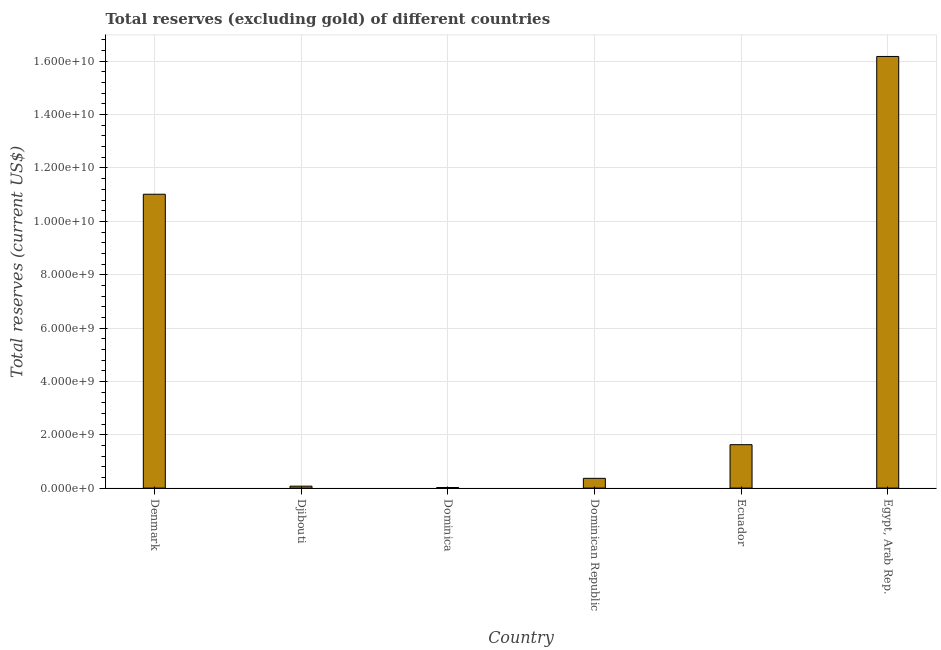What is the title of the graph?
Your answer should be compact. Total reserves (excluding gold) of different countries. What is the label or title of the X-axis?
Keep it short and to the point. Country. What is the label or title of the Y-axis?
Offer a terse response. Total reserves (current US$). What is the total reserves (excluding gold) in Dominica?
Your answer should be very brief. 2.21e+07. Across all countries, what is the maximum total reserves (excluding gold)?
Your answer should be very brief. 1.62e+1. Across all countries, what is the minimum total reserves (excluding gold)?
Make the answer very short. 2.21e+07. In which country was the total reserves (excluding gold) maximum?
Keep it short and to the point. Egypt, Arab Rep. In which country was the total reserves (excluding gold) minimum?
Offer a terse response. Dominica. What is the sum of the total reserves (excluding gold)?
Keep it short and to the point. 2.93e+1. What is the difference between the total reserves (excluding gold) in Dominican Republic and Ecuador?
Your response must be concise. -1.26e+09. What is the average total reserves (excluding gold) per country?
Offer a very short reply. 4.88e+09. What is the median total reserves (excluding gold)?
Your answer should be compact. 9.97e+08. What is the ratio of the total reserves (excluding gold) in Denmark to that in Dominican Republic?
Ensure brevity in your answer.  30.13. Is the total reserves (excluding gold) in Denmark less than that in Ecuador?
Offer a very short reply. No. What is the difference between the highest and the second highest total reserves (excluding gold)?
Your response must be concise. 5.17e+09. What is the difference between the highest and the lowest total reserves (excluding gold)?
Keep it short and to the point. 1.62e+1. How many bars are there?
Provide a succinct answer. 6. Are all the bars in the graph horizontal?
Your answer should be compact. No. Are the values on the major ticks of Y-axis written in scientific E-notation?
Offer a terse response. Yes. What is the Total reserves (current US$) in Denmark?
Make the answer very short. 1.10e+1. What is the Total reserves (current US$) in Djibouti?
Offer a terse response. 7.22e+07. What is the Total reserves (current US$) in Dominica?
Provide a short and direct response. 2.21e+07. What is the Total reserves (current US$) of Dominican Republic?
Your response must be concise. 3.66e+08. What is the Total reserves (current US$) in Ecuador?
Your answer should be compact. 1.63e+09. What is the Total reserves (current US$) of Egypt, Arab Rep.?
Make the answer very short. 1.62e+1. What is the difference between the Total reserves (current US$) in Denmark and Djibouti?
Keep it short and to the point. 1.09e+1. What is the difference between the Total reserves (current US$) in Denmark and Dominica?
Make the answer very short. 1.10e+1. What is the difference between the Total reserves (current US$) in Denmark and Dominican Republic?
Your answer should be compact. 1.07e+1. What is the difference between the Total reserves (current US$) in Denmark and Ecuador?
Make the answer very short. 9.39e+09. What is the difference between the Total reserves (current US$) in Denmark and Egypt, Arab Rep.?
Provide a short and direct response. -5.17e+09. What is the difference between the Total reserves (current US$) in Djibouti and Dominica?
Offer a terse response. 5.00e+07. What is the difference between the Total reserves (current US$) in Djibouti and Dominican Republic?
Offer a terse response. -2.93e+08. What is the difference between the Total reserves (current US$) in Djibouti and Ecuador?
Your answer should be very brief. -1.56e+09. What is the difference between the Total reserves (current US$) in Djibouti and Egypt, Arab Rep.?
Provide a succinct answer. -1.61e+1. What is the difference between the Total reserves (current US$) in Dominica and Dominican Republic?
Make the answer very short. -3.43e+08. What is the difference between the Total reserves (current US$) in Dominica and Ecuador?
Your answer should be compact. -1.61e+09. What is the difference between the Total reserves (current US$) in Dominica and Egypt, Arab Rep.?
Keep it short and to the point. -1.62e+1. What is the difference between the Total reserves (current US$) in Dominican Republic and Ecuador?
Offer a terse response. -1.26e+09. What is the difference between the Total reserves (current US$) in Dominican Republic and Egypt, Arab Rep.?
Your answer should be very brief. -1.58e+1. What is the difference between the Total reserves (current US$) in Ecuador and Egypt, Arab Rep.?
Give a very brief answer. -1.46e+1. What is the ratio of the Total reserves (current US$) in Denmark to that in Djibouti?
Your answer should be compact. 152.67. What is the ratio of the Total reserves (current US$) in Denmark to that in Dominica?
Provide a short and direct response. 497.92. What is the ratio of the Total reserves (current US$) in Denmark to that in Dominican Republic?
Offer a terse response. 30.13. What is the ratio of the Total reserves (current US$) in Denmark to that in Ecuador?
Your answer should be compact. 6.77. What is the ratio of the Total reserves (current US$) in Denmark to that in Egypt, Arab Rep.?
Give a very brief answer. 0.68. What is the ratio of the Total reserves (current US$) in Djibouti to that in Dominica?
Provide a short and direct response. 3.26. What is the ratio of the Total reserves (current US$) in Djibouti to that in Dominican Republic?
Make the answer very short. 0.2. What is the ratio of the Total reserves (current US$) in Djibouti to that in Ecuador?
Your answer should be very brief. 0.04. What is the ratio of the Total reserves (current US$) in Djibouti to that in Egypt, Arab Rep.?
Give a very brief answer. 0. What is the ratio of the Total reserves (current US$) in Dominica to that in Dominican Republic?
Your response must be concise. 0.06. What is the ratio of the Total reserves (current US$) in Dominica to that in Ecuador?
Offer a terse response. 0.01. What is the ratio of the Total reserves (current US$) in Dominica to that in Egypt, Arab Rep.?
Your response must be concise. 0. What is the ratio of the Total reserves (current US$) in Dominican Republic to that in Ecuador?
Make the answer very short. 0.23. What is the ratio of the Total reserves (current US$) in Dominican Republic to that in Egypt, Arab Rep.?
Provide a short and direct response. 0.02. What is the ratio of the Total reserves (current US$) in Ecuador to that in Egypt, Arab Rep.?
Provide a short and direct response. 0.1. 